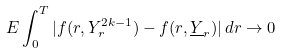<formula> <loc_0><loc_0><loc_500><loc_500>E \int ^ { T } _ { 0 } | f ( r , Y ^ { 2 k - 1 } _ { r } ) - f ( r , \underline { Y } _ { r } ) | \, d r \rightarrow 0</formula> 